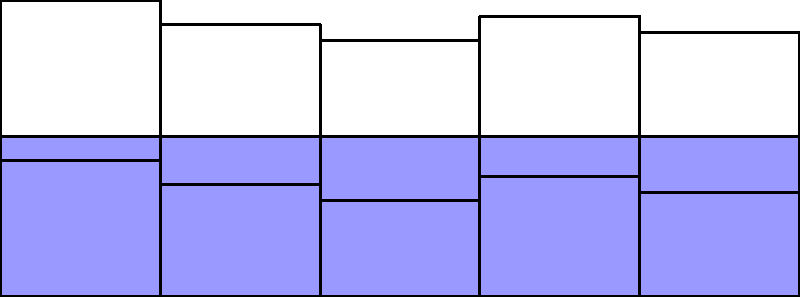Based on the bar chart showing COVID-19 vaccination rates among different racial groups, which group has the highest vaccination rate, and what is the absolute difference in vaccination rates between the highest and lowest groups? To answer this question, we need to follow these steps:

1. Identify the highest vaccination rate:
   - White: 85%
   - Black: 70%
   - Hispanic: 60%
   - Asian: 75%
   - Other: 65%
   The highest vaccination rate is 85% for the White racial group.

2. Identify the lowest vaccination rate:
   The lowest vaccination rate is 60% for the Hispanic racial group.

3. Calculate the absolute difference:
   Absolute difference = Highest rate - Lowest rate
   $$ 85\% - 60\% = 25\% $$

Therefore, the White racial group has the highest vaccination rate, and the absolute difference between the highest (White) and lowest (Hispanic) vaccination rates is 25 percentage points.
Answer: White; 25 percentage points 